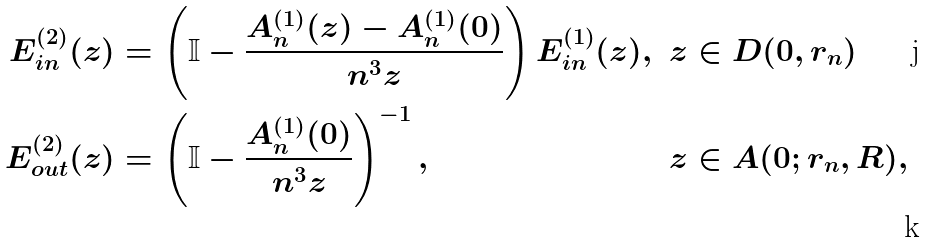Convert formula to latex. <formula><loc_0><loc_0><loc_500><loc_500>E ^ { ( 2 ) } _ { i n } ( z ) & = \left ( \mathbb { I } - \frac { A _ { n } ^ { ( 1 ) } ( z ) - A _ { n } ^ { ( 1 ) } ( 0 ) } { n ^ { 3 } z } \right ) E _ { i n } ^ { ( 1 ) } ( z ) , & & z \in D ( 0 , r _ { n } ) \\ E ^ { ( 2 ) } _ { o u t } ( z ) & = \left ( \mathbb { I } - \frac { A _ { n } ^ { ( 1 ) } ( 0 ) } { n ^ { 3 } z } \right ) ^ { - 1 } , & & z \in A ( 0 ; r _ { n } , R ) ,</formula> 